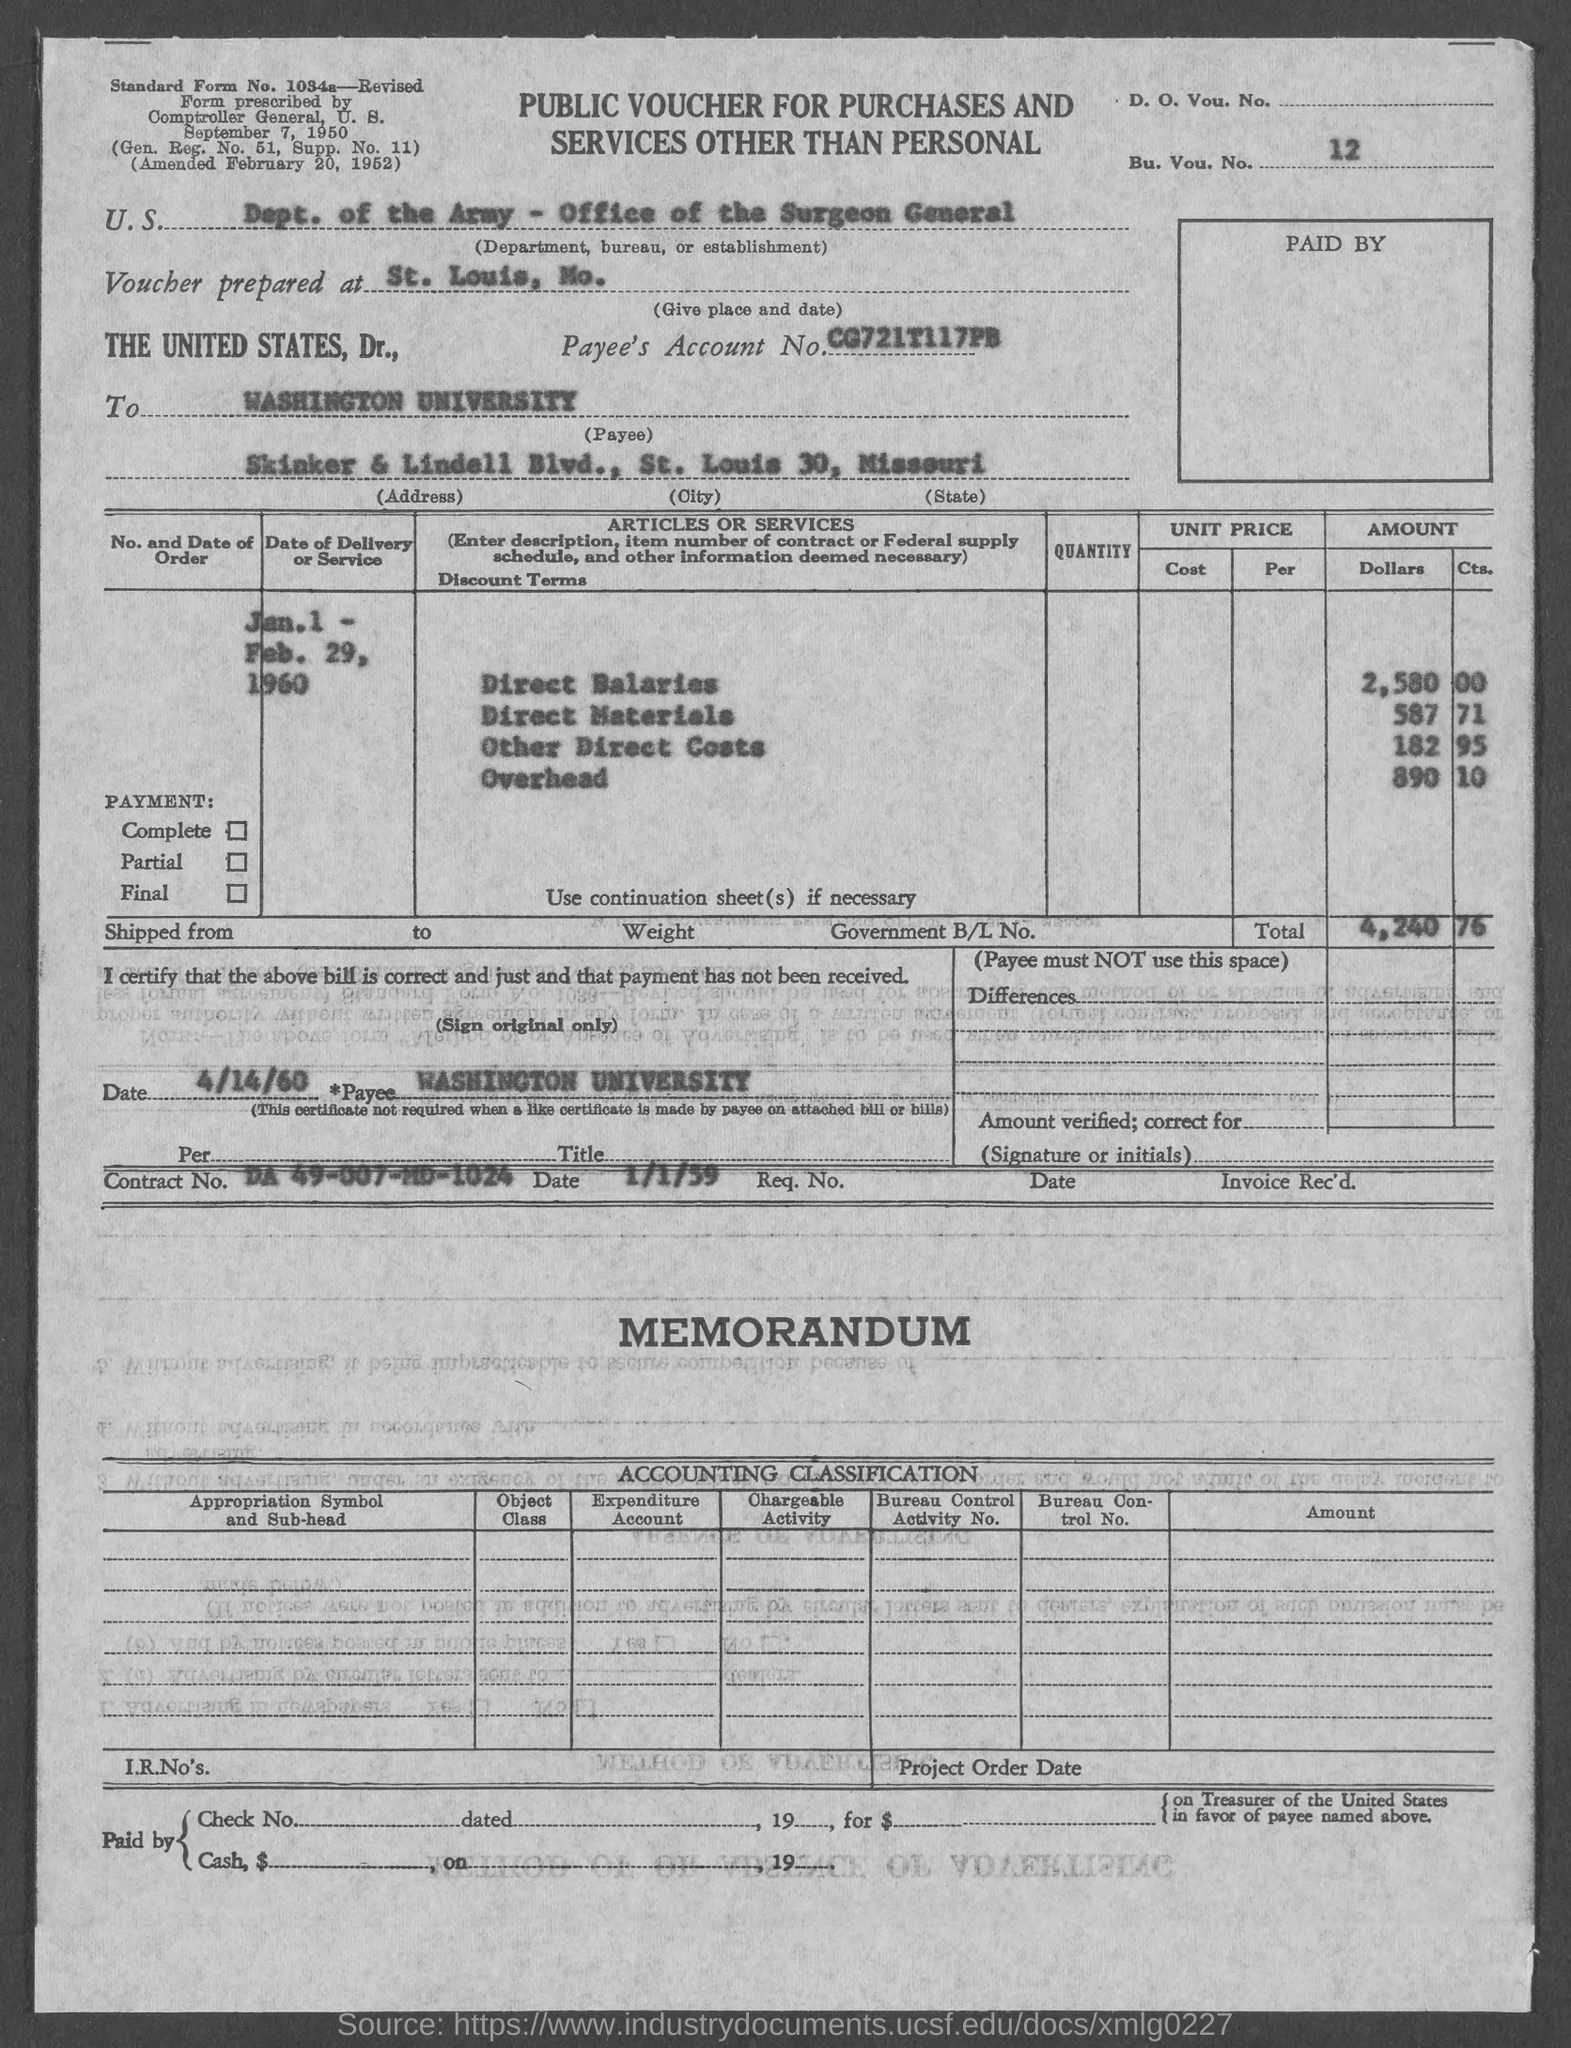Identify some key points in this picture. The voucher is prepared at St. Louis, Missouri. The payee address is located at Skinker & Lindell Blvd. The payee city is St. Louis, and the payment amount is 30... The Direct Materials amount is 587 with an estimated quantity of 71. The payee state is Missouri. 